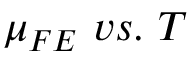Convert formula to latex. <formula><loc_0><loc_0><loc_500><loc_500>\mu _ { F E } \ v s . \ T</formula> 